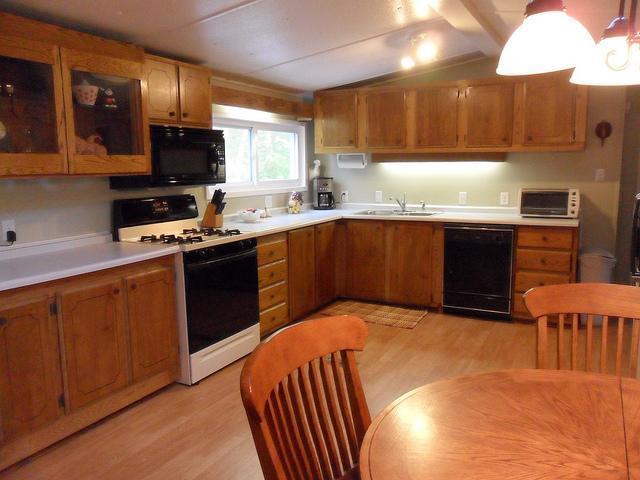How many chairs are there?
Give a very brief answer. 2. How many chairs are in the photo?
Give a very brief answer. 2. 